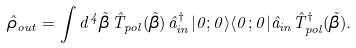<formula> <loc_0><loc_0><loc_500><loc_500>\hat { \rho } _ { o u t } = \int d ^ { 4 } \vec { \beta } \, \hat { T } _ { p o l } ( \vec { \beta } ) \, \hat { a } _ { i n } ^ { \dagger } | 0 ; 0 \rangle \langle 0 ; 0 | \hat { a } _ { i n } \hat { T } _ { p o l } ^ { \dagger } ( \vec { \beta } ) .</formula> 